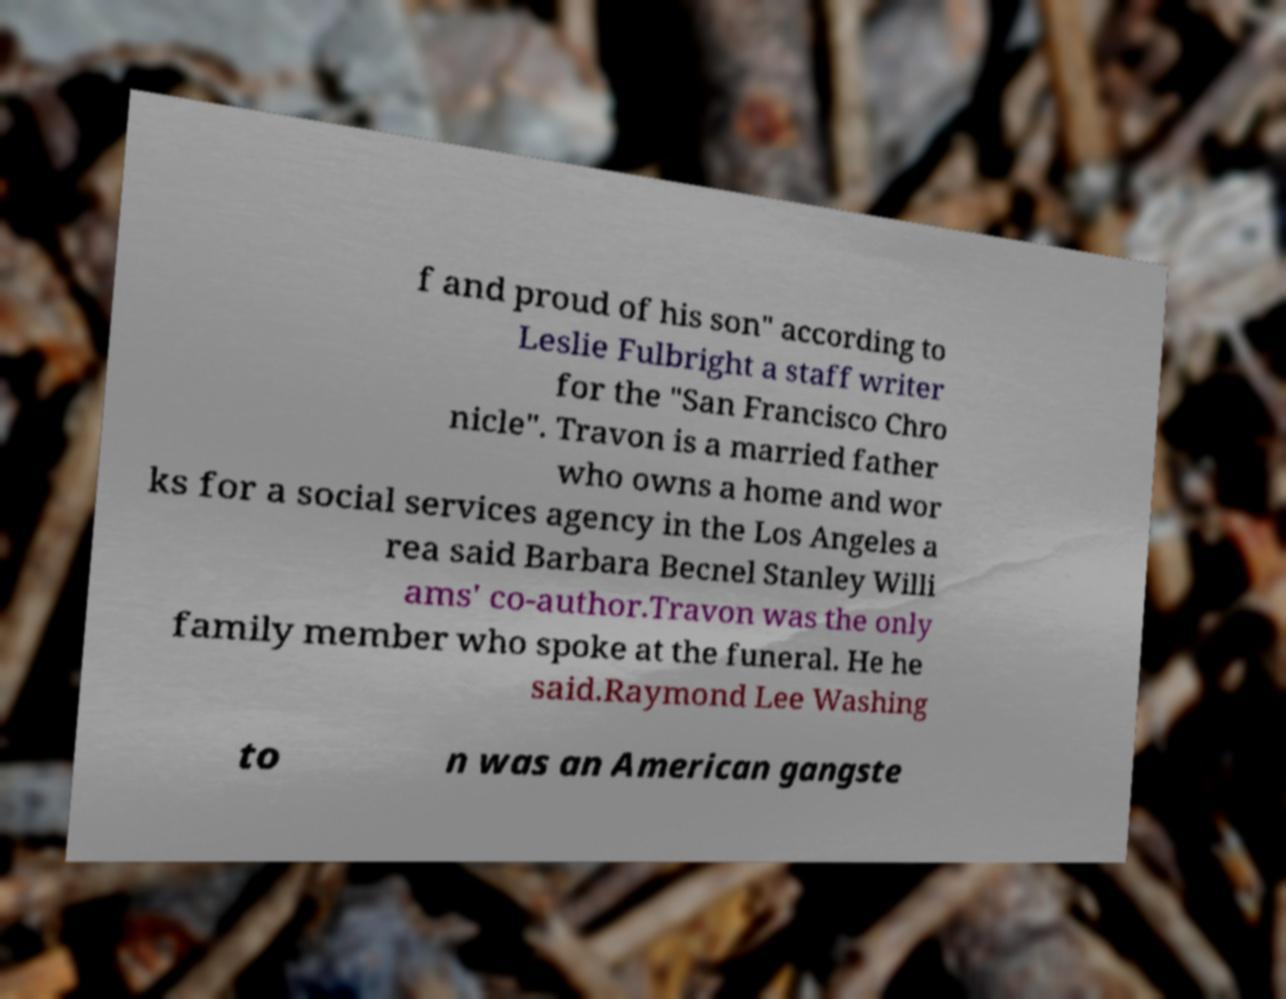Could you extract and type out the text from this image? f and proud of his son" according to Leslie Fulbright a staff writer for the "San Francisco Chro nicle". Travon is a married father who owns a home and wor ks for a social services agency in the Los Angeles a rea said Barbara Becnel Stanley Willi ams' co-author.Travon was the only family member who spoke at the funeral. He he said.Raymond Lee Washing to n was an American gangste 